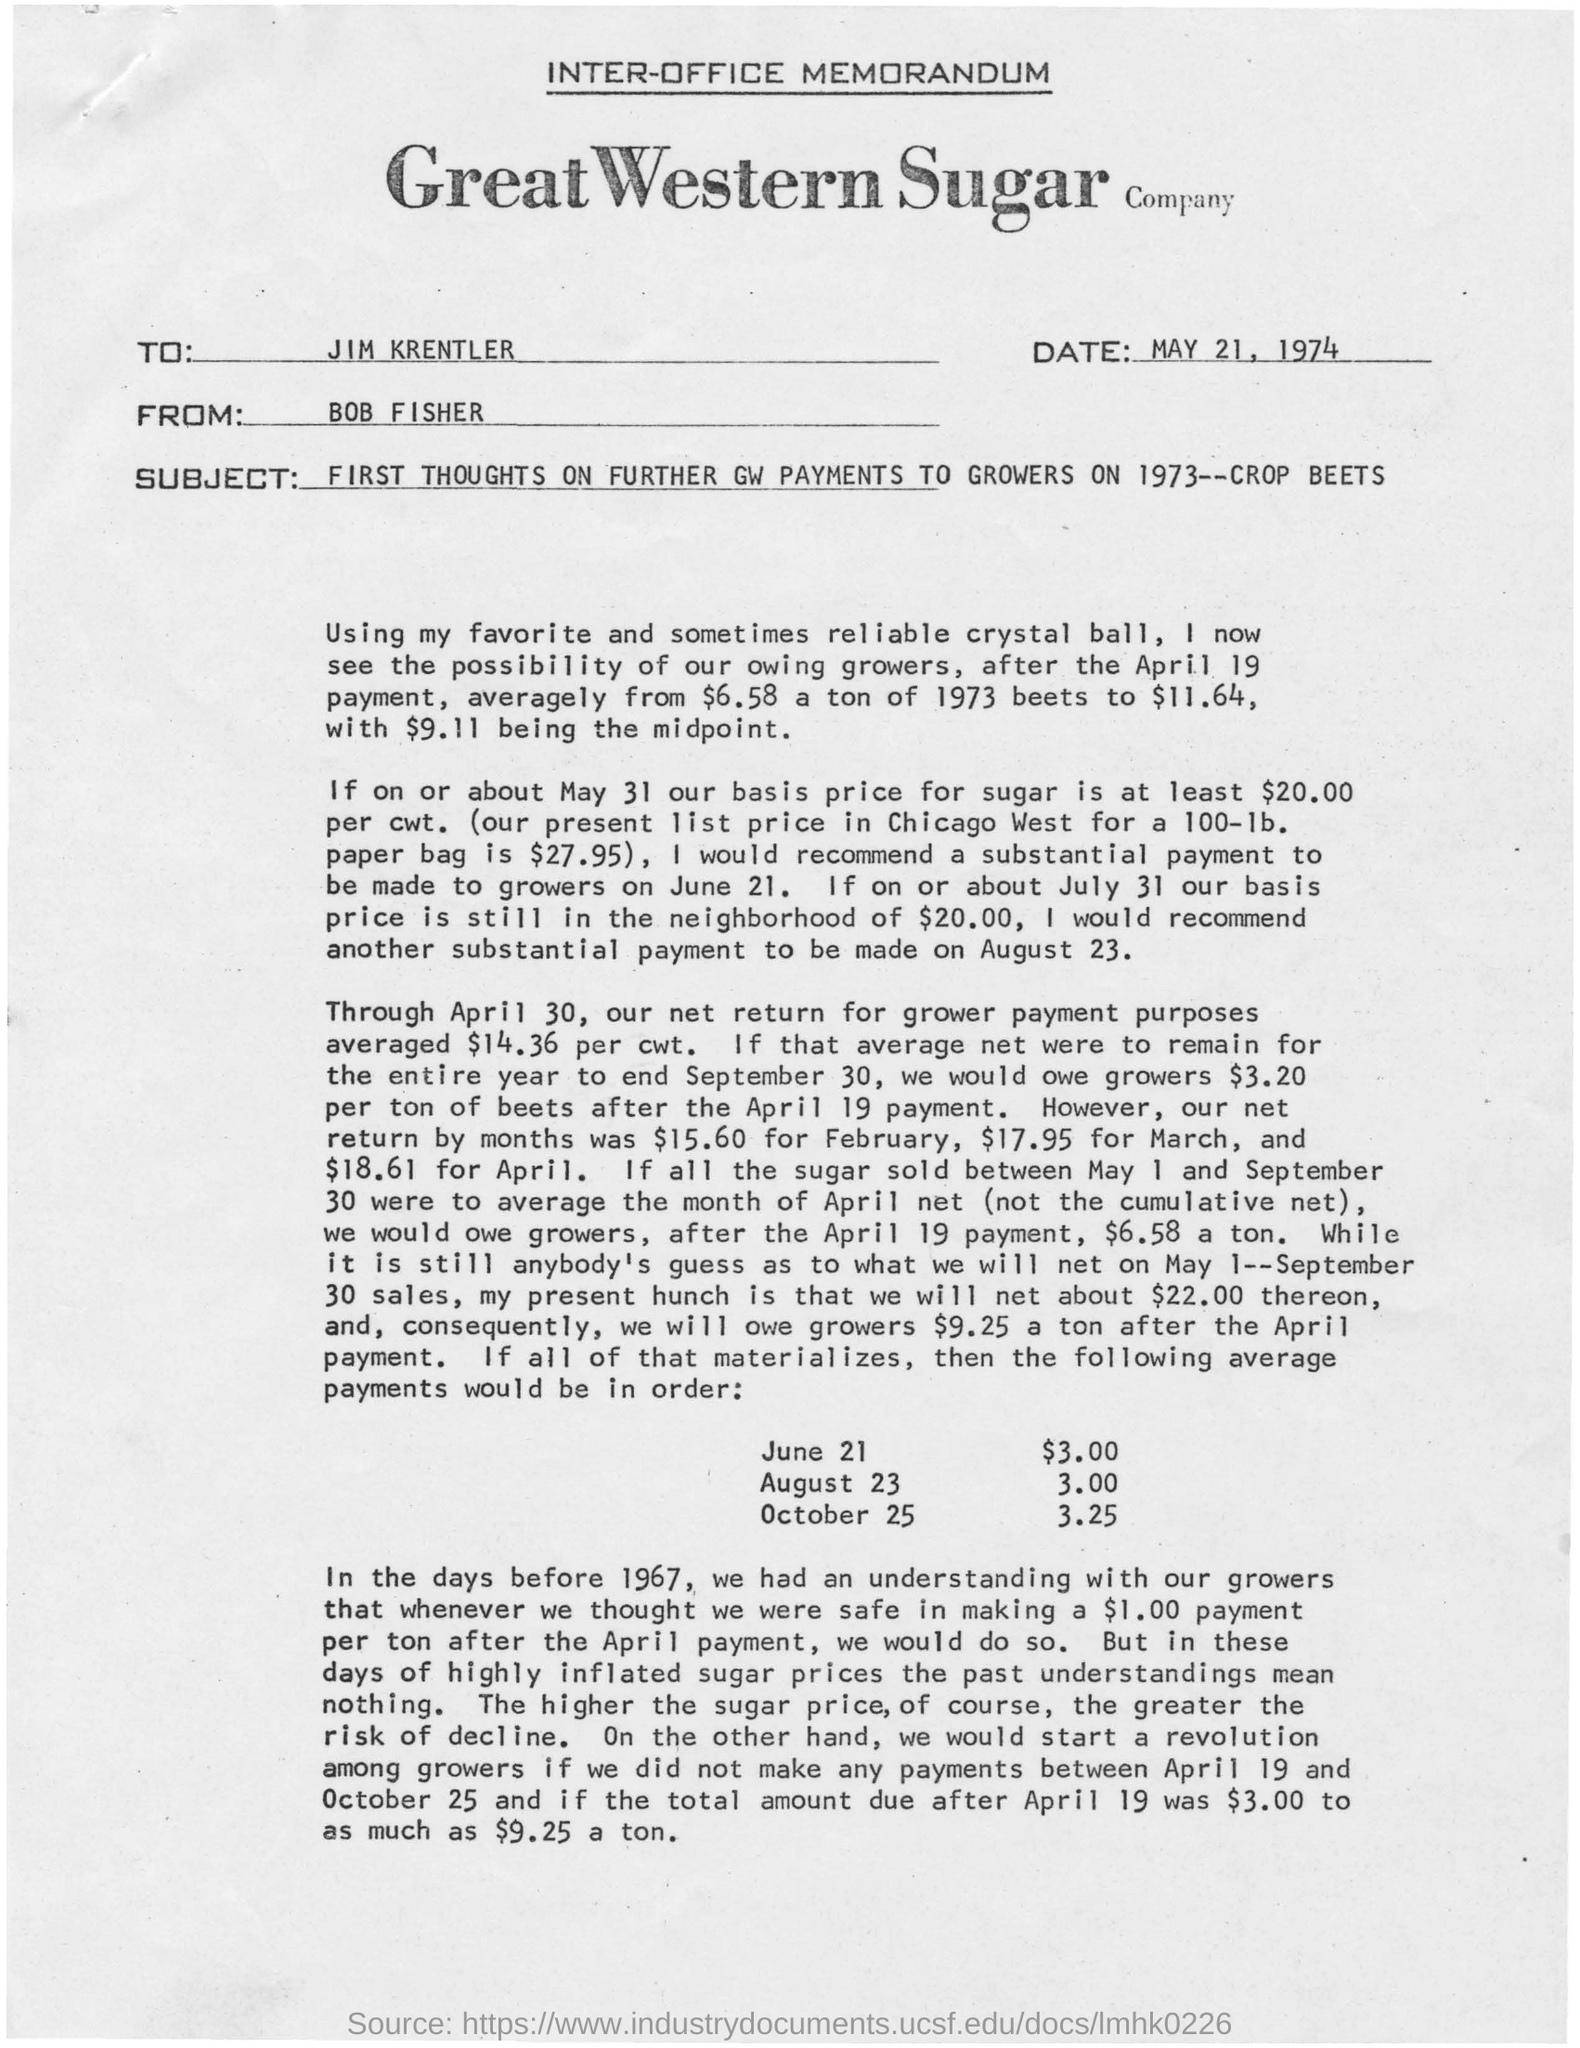What is written in top of the document ?
Provide a succinct answer. INTER-OFFICE MEMORANDUM. What is the Company Name ?
Ensure brevity in your answer.  GREAT WESTERN SUGAR COMPANY. What is the date mentioned in the document ?
Keep it short and to the point. MAY 21, 1974. Who sent this ?
Keep it short and to the point. BOB FISHER. Who is the recipient ?
Your response must be concise. JIM KRENTLER. What is the Subject Line of the document ?
Provide a short and direct response. FIRST THOUGHTS ON FURTHER GW PAYMENTS TO GROWERS ON 1973--CROP BEETS. 